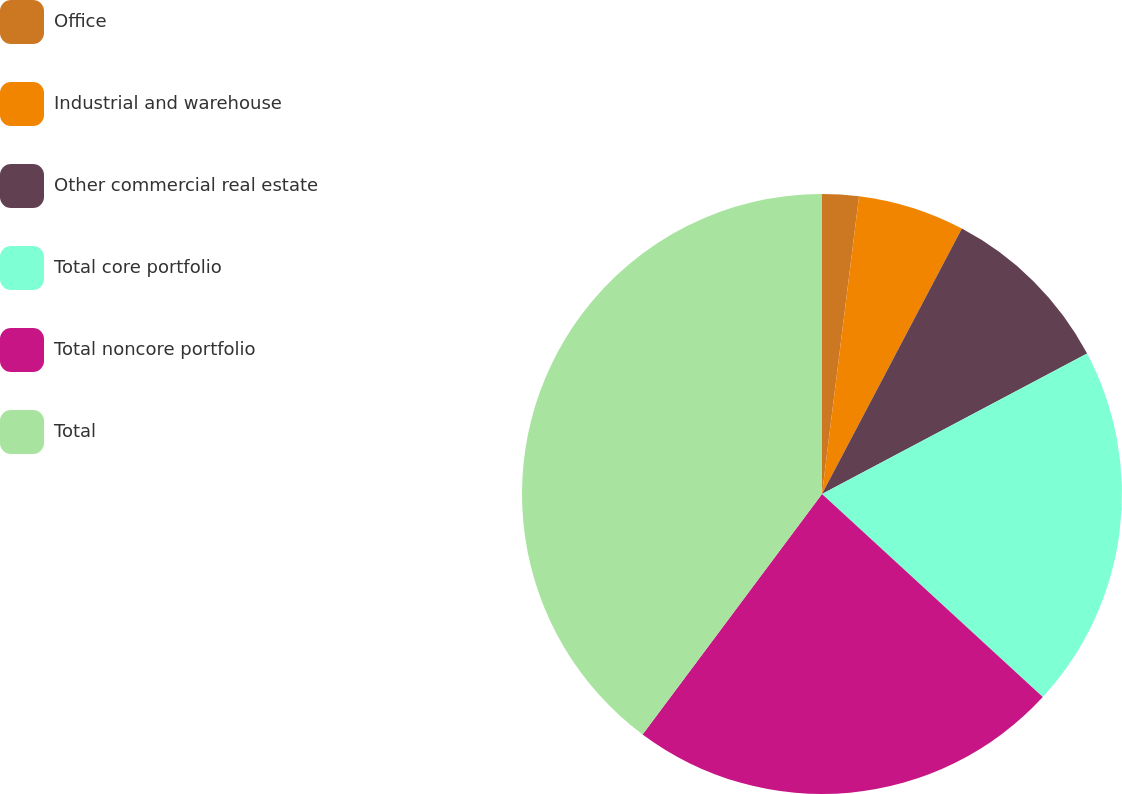<chart> <loc_0><loc_0><loc_500><loc_500><pie_chart><fcel>Office<fcel>Industrial and warehouse<fcel>Other commercial real estate<fcel>Total core portfolio<fcel>Total noncore portfolio<fcel>Total<nl><fcel>1.97%<fcel>5.75%<fcel>9.53%<fcel>19.59%<fcel>23.37%<fcel>39.8%<nl></chart> 